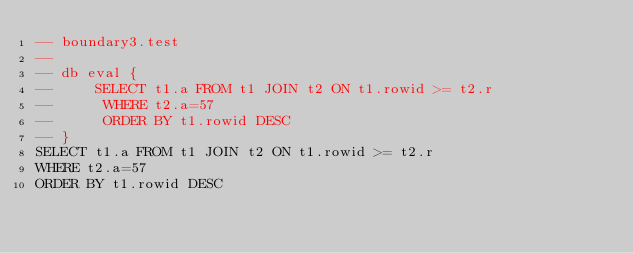Convert code to text. <code><loc_0><loc_0><loc_500><loc_500><_SQL_>-- boundary3.test
-- 
-- db eval {
--     SELECT t1.a FROM t1 JOIN t2 ON t1.rowid >= t2.r
--      WHERE t2.a=57
--      ORDER BY t1.rowid DESC
-- }
SELECT t1.a FROM t1 JOIN t2 ON t1.rowid >= t2.r
WHERE t2.a=57
ORDER BY t1.rowid DESC</code> 